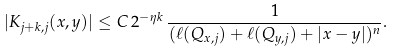<formula> <loc_0><loc_0><loc_500><loc_500>| K _ { j + k , j } ( x , y ) | \leq C \, 2 ^ { - \eta k } \, \frac { 1 } { ( \ell ( Q _ { x , j } ) + \ell ( Q _ { y , j } ) + | x - y | ) ^ { n } } .</formula> 